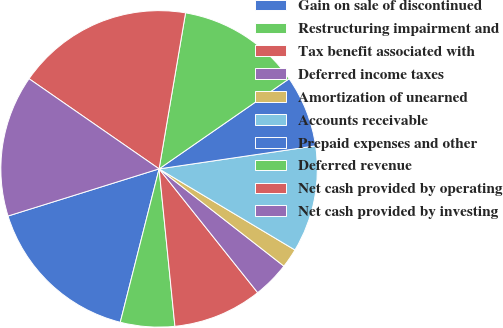<chart> <loc_0><loc_0><loc_500><loc_500><pie_chart><fcel>Gain on sale of discontinued<fcel>Restructuring impairment and<fcel>Tax benefit associated with<fcel>Deferred income taxes<fcel>Amortization of unearned<fcel>Accounts receivable<fcel>Prepaid expenses and other<fcel>Deferred revenue<fcel>Net cash provided by operating<fcel>Net cash provided by investing<nl><fcel>16.24%<fcel>5.54%<fcel>9.11%<fcel>3.76%<fcel>1.97%<fcel>10.89%<fcel>7.32%<fcel>12.68%<fcel>18.03%<fcel>14.46%<nl></chart> 